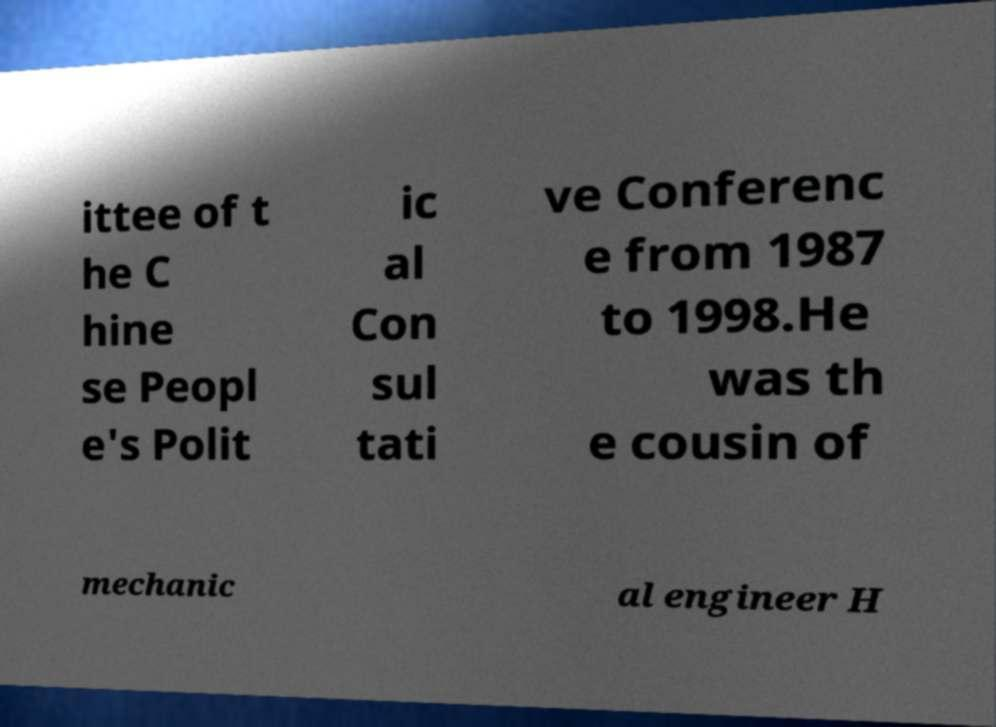Could you assist in decoding the text presented in this image and type it out clearly? ittee of t he C hine se Peopl e's Polit ic al Con sul tati ve Conferenc e from 1987 to 1998.He was th e cousin of mechanic al engineer H 